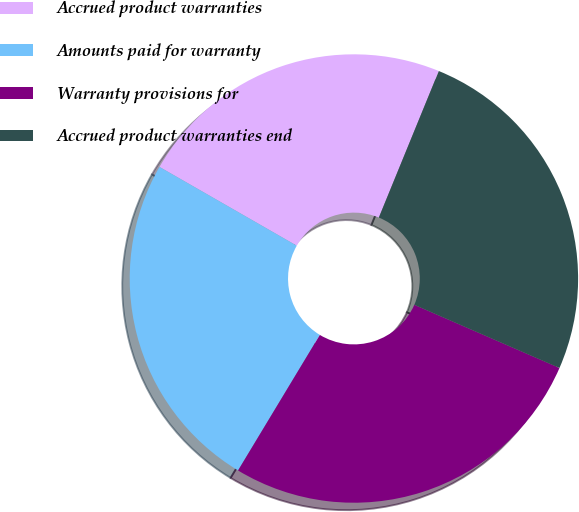Convert chart to OTSL. <chart><loc_0><loc_0><loc_500><loc_500><pie_chart><fcel>Accrued product warranties<fcel>Amounts paid for warranty<fcel>Warranty provisions for<fcel>Accrued product warranties end<nl><fcel>22.89%<fcel>24.65%<fcel>27.11%<fcel>25.35%<nl></chart> 